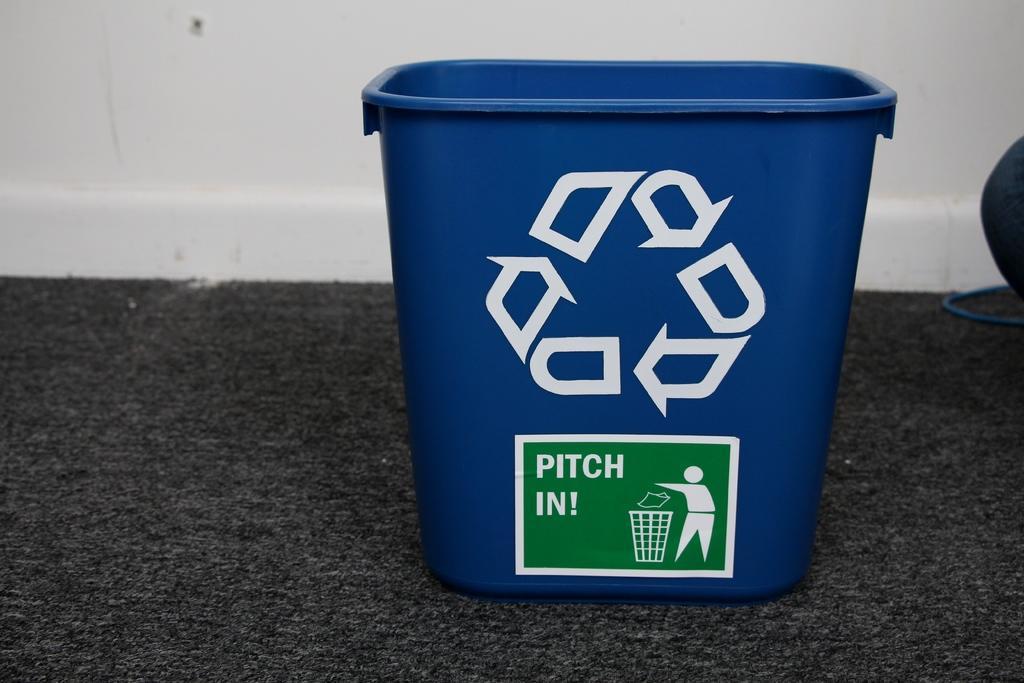Provide a one-sentence caption for the provided image. A blue recycling bin that says Pitch In on some dark carpet. 